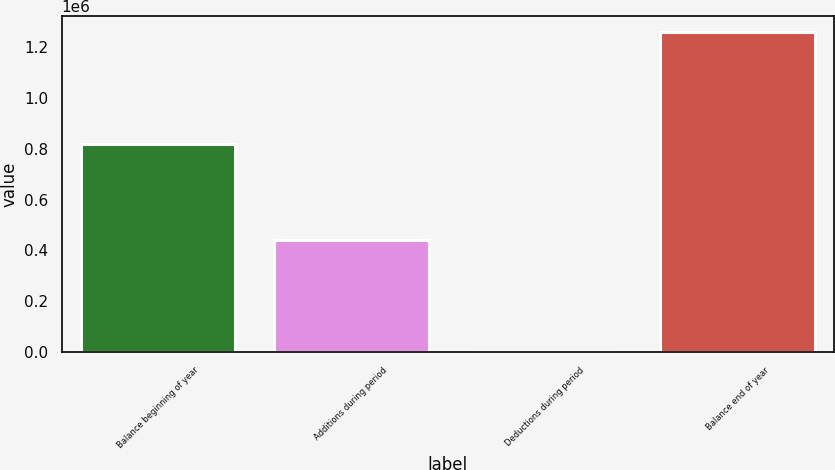Convert chart. <chart><loc_0><loc_0><loc_500><loc_500><bar_chart><fcel>Balance beginning of year<fcel>Additions during period<fcel>Deductions during period<fcel>Balance end of year<nl><fcel>818392<fcel>440934<fcel>816<fcel>1.25851e+06<nl></chart> 